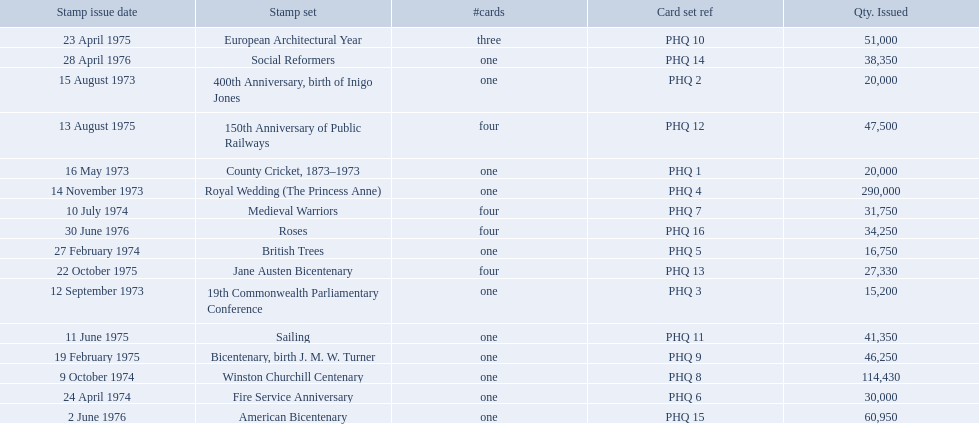Which stamp sets were issued? County Cricket, 1873–1973, 400th Anniversary, birth of Inigo Jones, 19th Commonwealth Parliamentary Conference, Royal Wedding (The Princess Anne), British Trees, Fire Service Anniversary, Medieval Warriors, Winston Churchill Centenary, Bicentenary, birth J. M. W. Turner, European Architectural Year, Sailing, 150th Anniversary of Public Railways, Jane Austen Bicentenary, Social Reformers, American Bicentenary, Roses. Of those stamp sets, which had more that 200,000 issued? Royal Wedding (The Princess Anne). 